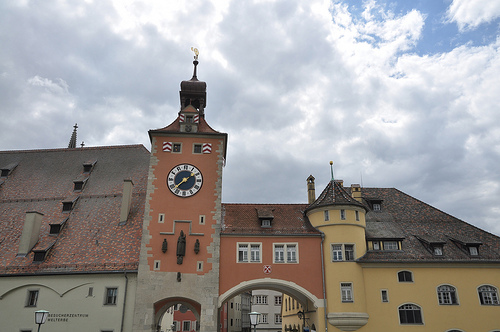Please provide the bounding box coordinate of the region this sentence describes: building has a window. The coordinates of the region where the building has a window are approximately [0.87, 0.73, 0.91, 0.77]. 